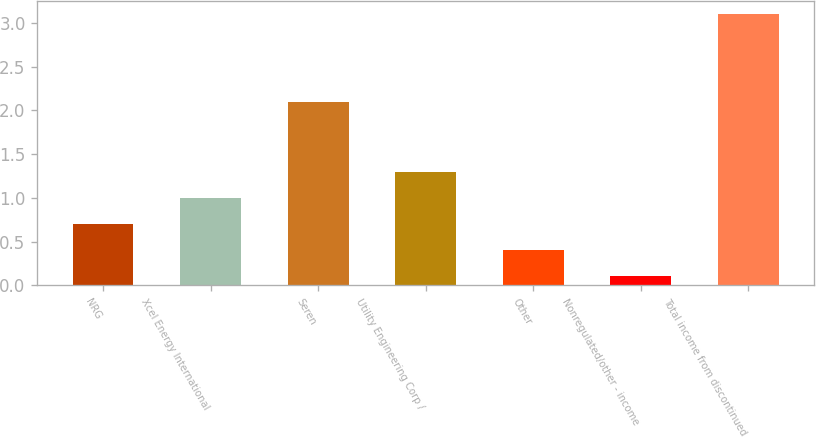Convert chart. <chart><loc_0><loc_0><loc_500><loc_500><bar_chart><fcel>NRG<fcel>Xcel Energy International<fcel>Seren<fcel>Utility Engineering Corp /<fcel>Other<fcel>Nonregulated/other - income<fcel>Total income from discontinued<nl><fcel>0.7<fcel>1<fcel>2.1<fcel>1.3<fcel>0.4<fcel>0.1<fcel>3.1<nl></chart> 